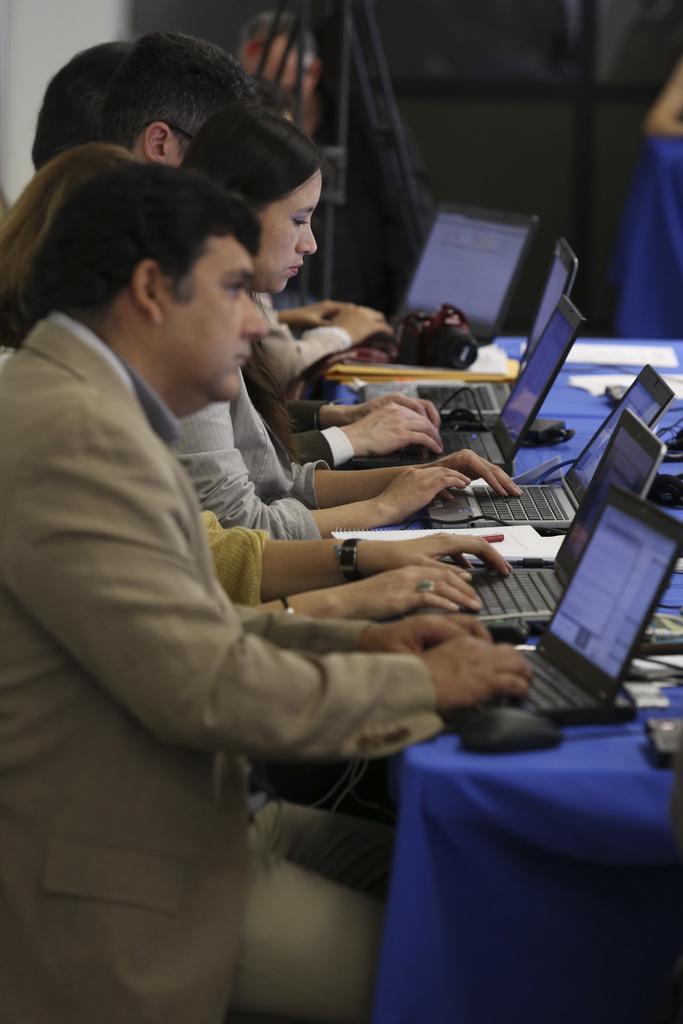How would you summarize this image in a sentence or two? In this image we can see many persons sitting at the table. On the table we can see laptops, mouses, camera and papers. In the background there is curtain and wall. 